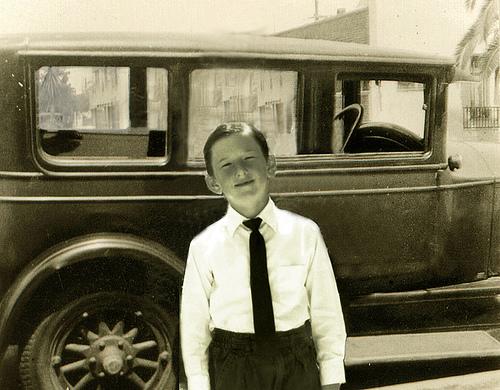Why is the little boy wearing a tie?
Quick response, please. Going to church. Was the car manufactured in 2010?
Write a very short answer. No. Is this a new picture or an old picture?
Answer briefly. Old. 